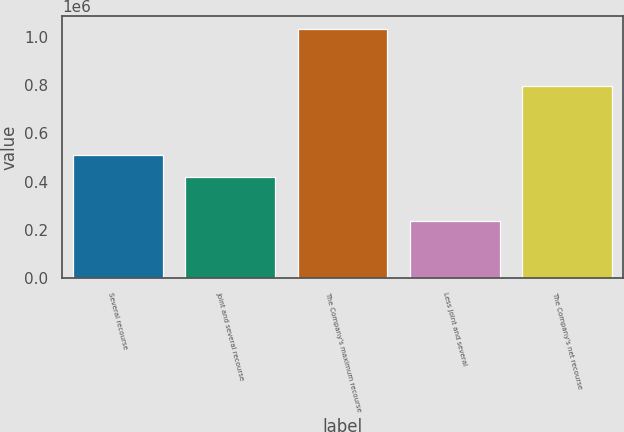Convert chart to OTSL. <chart><loc_0><loc_0><loc_500><loc_500><bar_chart><fcel>Several recourse<fcel>Joint and several recourse<fcel>The Company's maximum recourse<fcel>Less joint and several<fcel>The Company's net recourse<nl><fcel>511873<fcel>420813<fcel>1.03363e+06<fcel>238692<fcel>794934<nl></chart> 